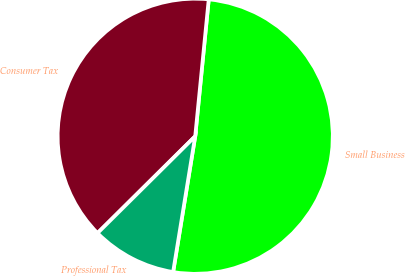<chart> <loc_0><loc_0><loc_500><loc_500><pie_chart><fcel>Small Business<fcel>Consumer Tax<fcel>Professional Tax<nl><fcel>51.0%<fcel>39.0%<fcel>10.0%<nl></chart> 